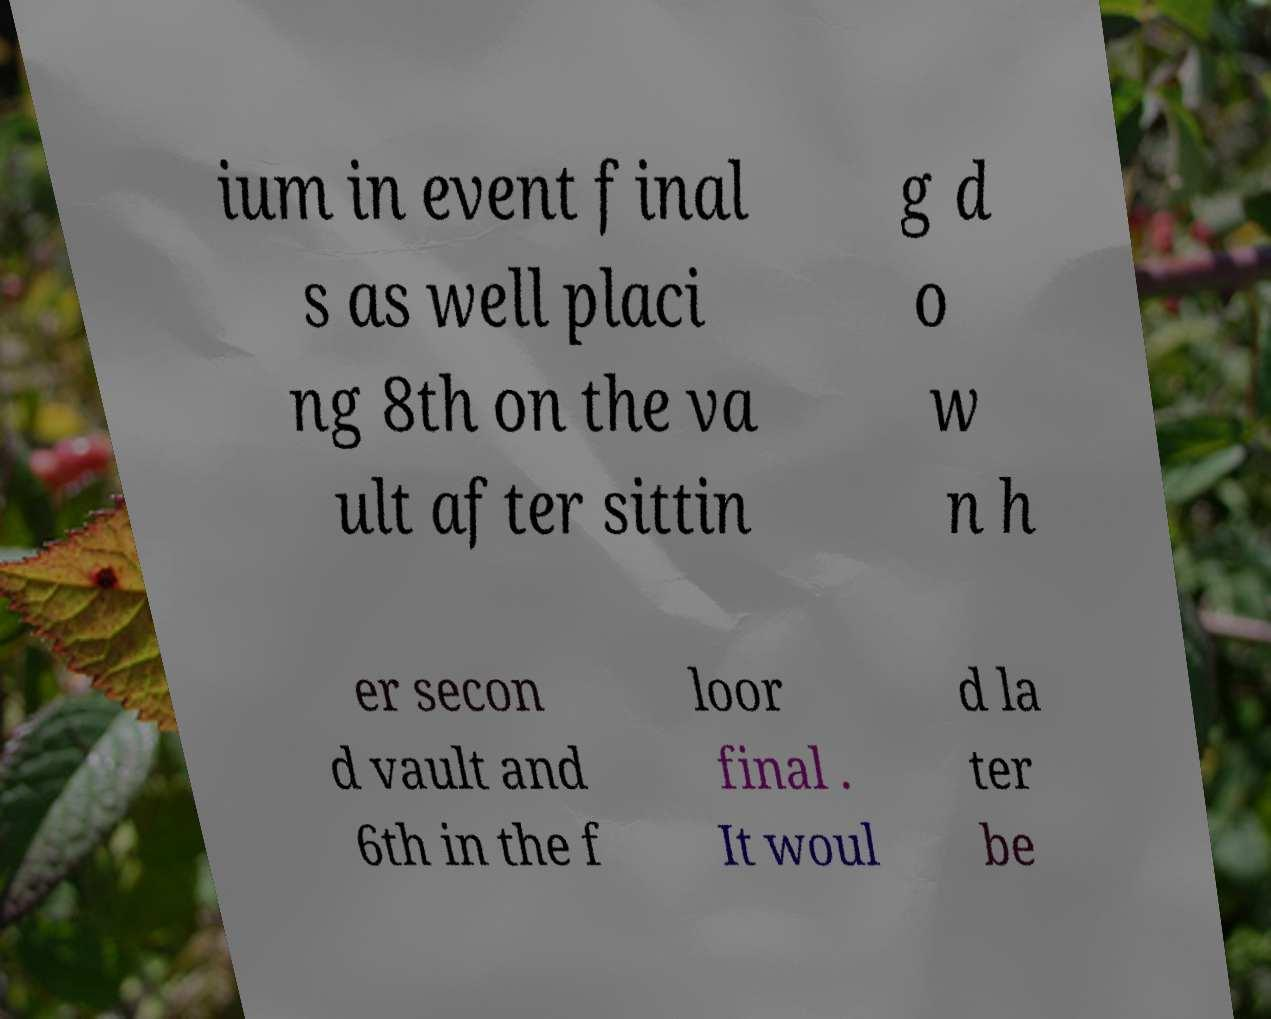Please identify and transcribe the text found in this image. ium in event final s as well placi ng 8th on the va ult after sittin g d o w n h er secon d vault and 6th in the f loor final . It woul d la ter be 